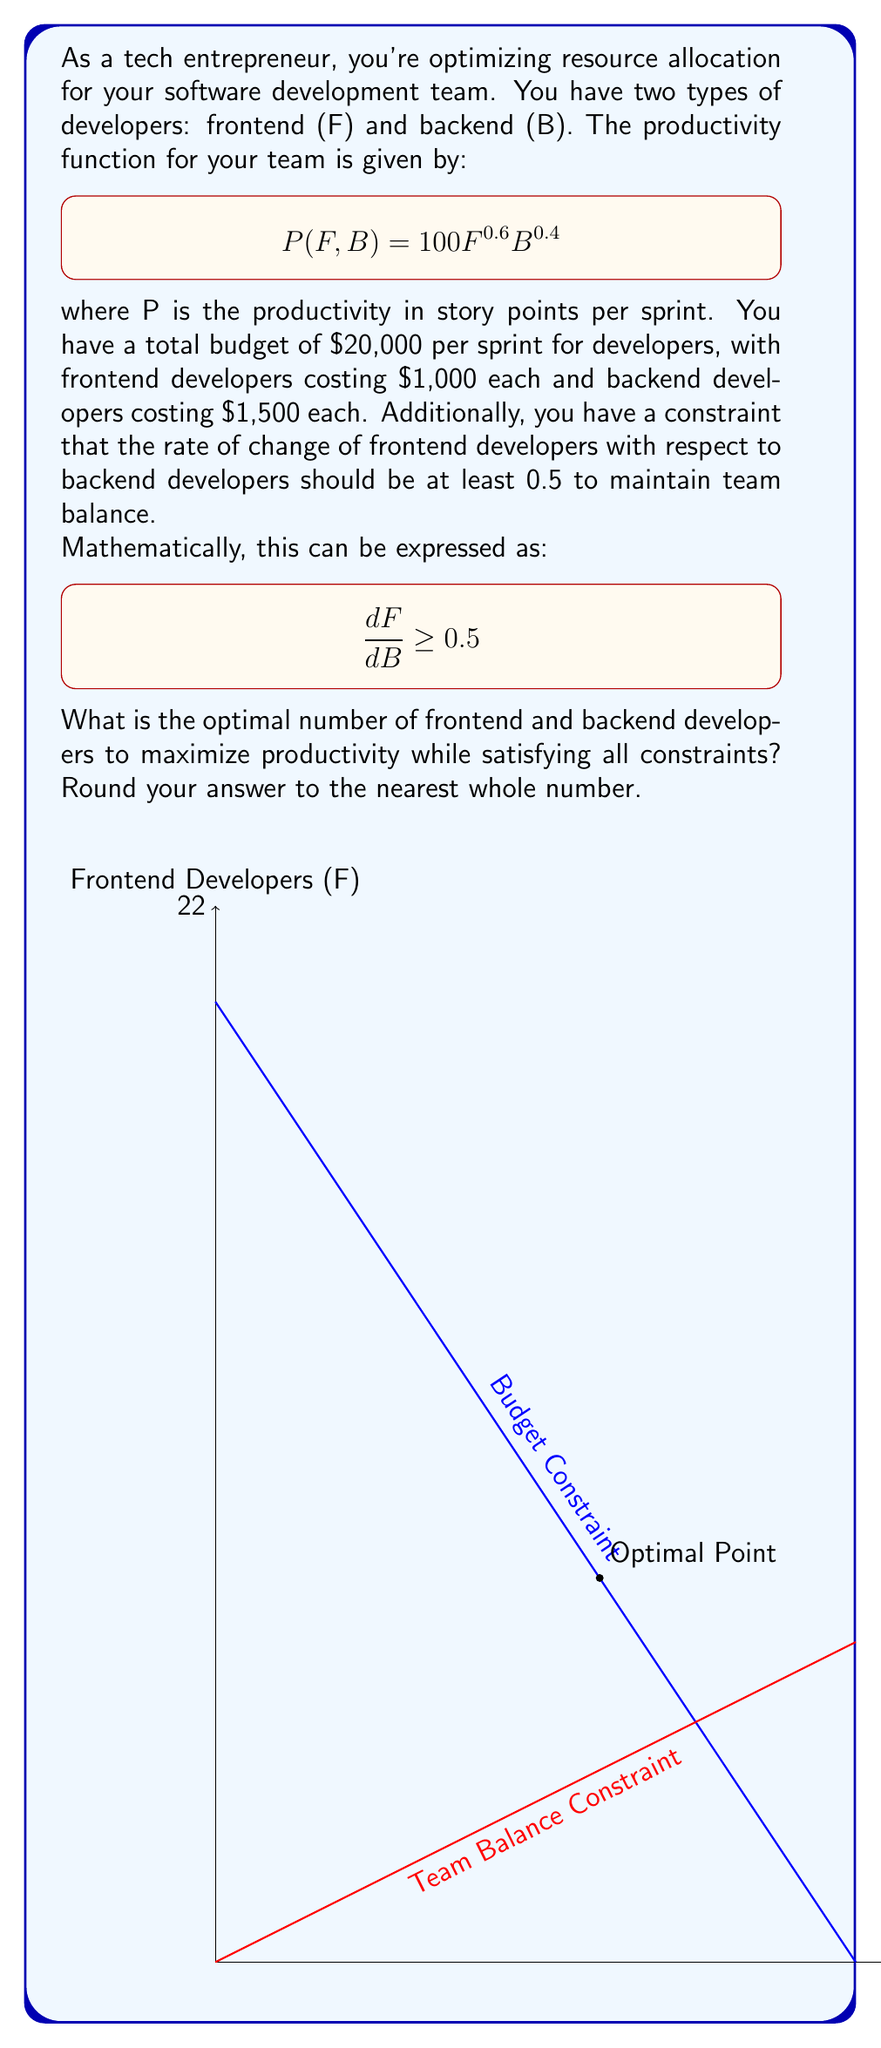Can you solve this math problem? Let's approach this step-by-step:

1) First, we need to set up our optimization problem:
   Maximize: $$P(F, B) = 100F^{0.6}B^{0.4}$$
   Subject to:
   $$1000F + 1500B \leq 20000$$ (budget constraint)
   $$\frac{dF}{dB} \geq 0.5$$ (team balance constraint)

2) The budget constraint can be rewritten as:
   $$F = 20 - 1.5B$$

3) The team balance constraint $$\frac{dF}{dB} \geq 0.5$$ implies that $$F \geq 0.5B + C$$ for some constant C.

4) The optimal solution will occur where these two constraints intersect:
   $$20 - 1.5B = 0.5B + C$$
   $$20 - C = 2B$$
   $$B = 10 - 0.5C$$

5) Substituting this back into the budget constraint:
   $$F = 20 - 1.5(10 - 0.5C) = 5 + 0.75C$$

6) The intersection point occurs when C = 4, giving:
   $$B = 8$$ and $$F = 8$$

7) To verify this is the optimal point, we can check that it satisfies both constraints:
   Budget: $1000(8) + 1500(8) = 20000$
   Team balance: $\frac{dF}{dB} = 1 > 0.5$

8) The productivity at this point is:
   $$P(8, 8) = 100(8^{0.6})(8^{0.4}) = 800$$
Answer: 8 frontend developers, 8 backend developers 